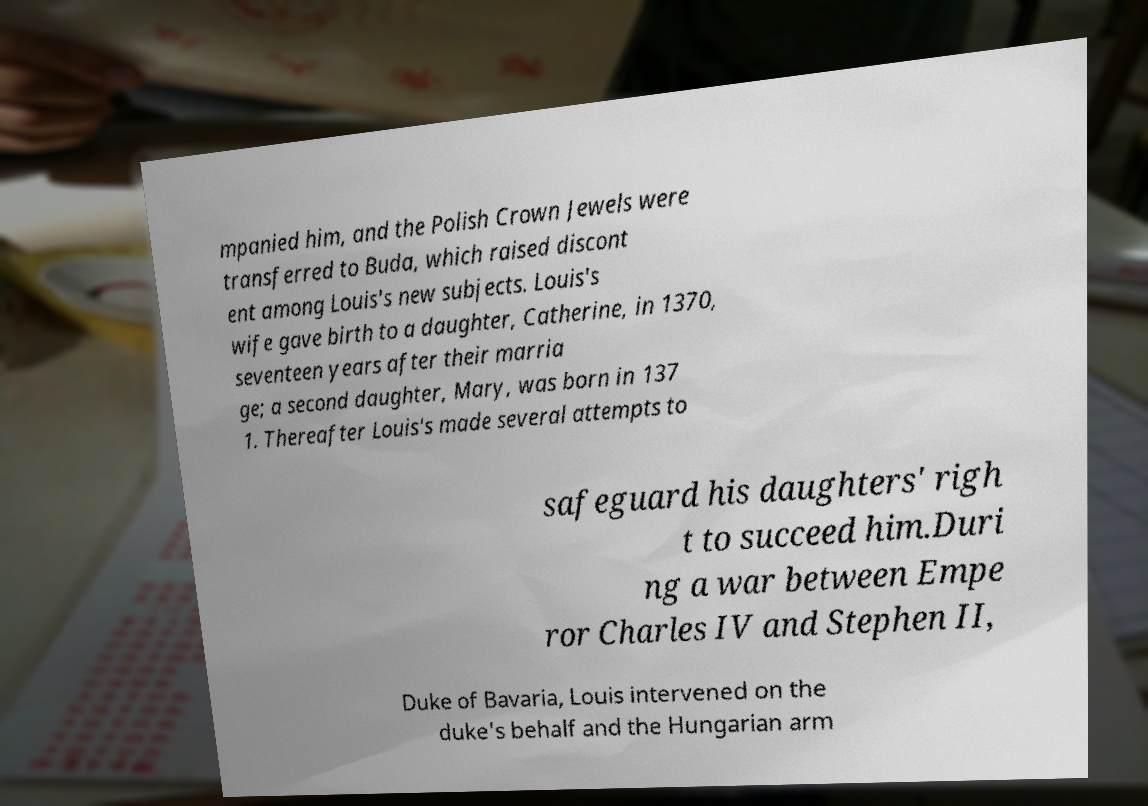There's text embedded in this image that I need extracted. Can you transcribe it verbatim? mpanied him, and the Polish Crown Jewels were transferred to Buda, which raised discont ent among Louis's new subjects. Louis's wife gave birth to a daughter, Catherine, in 1370, seventeen years after their marria ge; a second daughter, Mary, was born in 137 1. Thereafter Louis's made several attempts to safeguard his daughters' righ t to succeed him.Duri ng a war between Empe ror Charles IV and Stephen II, Duke of Bavaria, Louis intervened on the duke's behalf and the Hungarian arm 